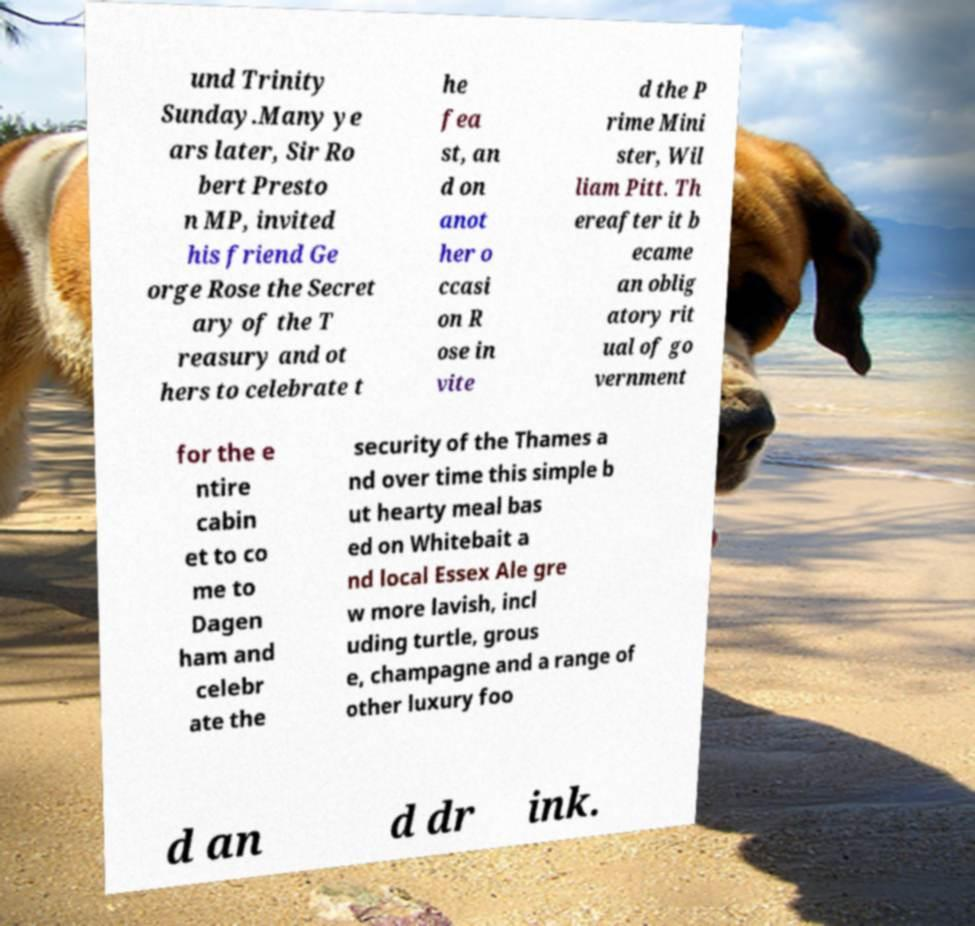What messages or text are displayed in this image? I need them in a readable, typed format. und Trinity Sunday.Many ye ars later, Sir Ro bert Presto n MP, invited his friend Ge orge Rose the Secret ary of the T reasury and ot hers to celebrate t he fea st, an d on anot her o ccasi on R ose in vite d the P rime Mini ster, Wil liam Pitt. Th ereafter it b ecame an oblig atory rit ual of go vernment for the e ntire cabin et to co me to Dagen ham and celebr ate the security of the Thames a nd over time this simple b ut hearty meal bas ed on Whitebait a nd local Essex Ale gre w more lavish, incl uding turtle, grous e, champagne and a range of other luxury foo d an d dr ink. 